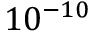<formula> <loc_0><loc_0><loc_500><loc_500>1 0 ^ { - 1 0 }</formula> 